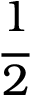Convert formula to latex. <formula><loc_0><loc_0><loc_500><loc_500>\cfrac { 1 } { 2 }</formula> 